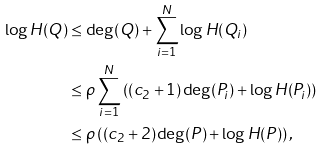<formula> <loc_0><loc_0><loc_500><loc_500>\log H ( Q ) & \leq \deg ( Q ) + \sum _ { i = 1 } ^ { N } \log H ( Q _ { i } ) \\ & \leq \rho \sum _ { i = 1 } ^ { N } \left ( ( c _ { 2 } + 1 ) \deg ( P _ { i } ) + \log H ( P _ { i } ) \right ) \\ & \leq \rho \left ( ( c _ { 2 } + 2 ) \deg ( P ) + \log H ( P ) \right ) ,</formula> 